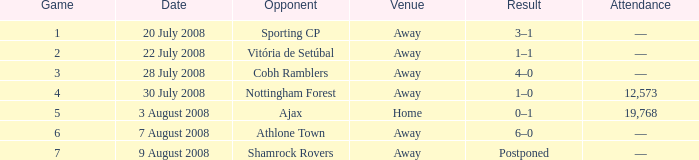What is the location of game 3? Away. 